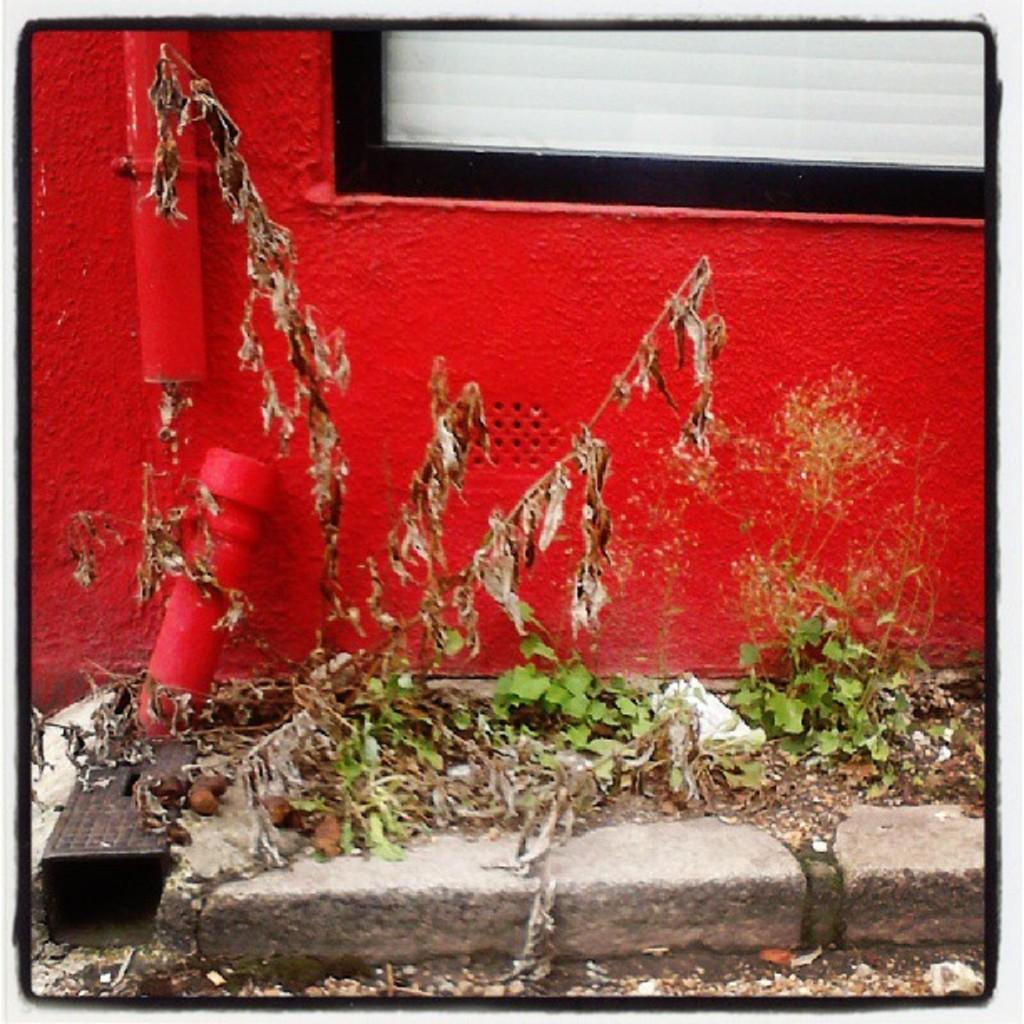What color is the wall in the image? The wall in the image is red. What is attached to the red wall? There is a red color pipe attached to the wall. What type of plant can be seen in the image? There is a dried plant in the image. Are there any other plants in the image? Yes, there are other plants beside the dried plant. What type of vest is the prison guard wearing in the image? There is no prison or prison guard present in the image. What type of farm animals can be seen in the image? There are no farm animals present in the image. 